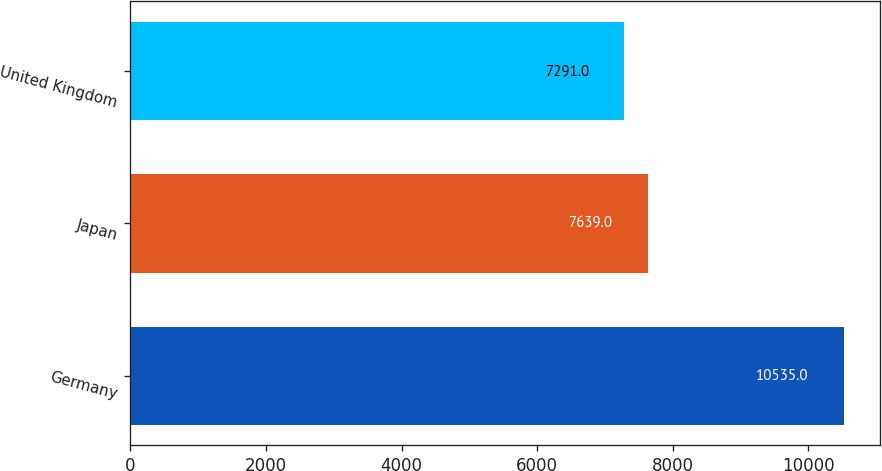Convert chart. <chart><loc_0><loc_0><loc_500><loc_500><bar_chart><fcel>Germany<fcel>Japan<fcel>United Kingdom<nl><fcel>10535<fcel>7639<fcel>7291<nl></chart> 